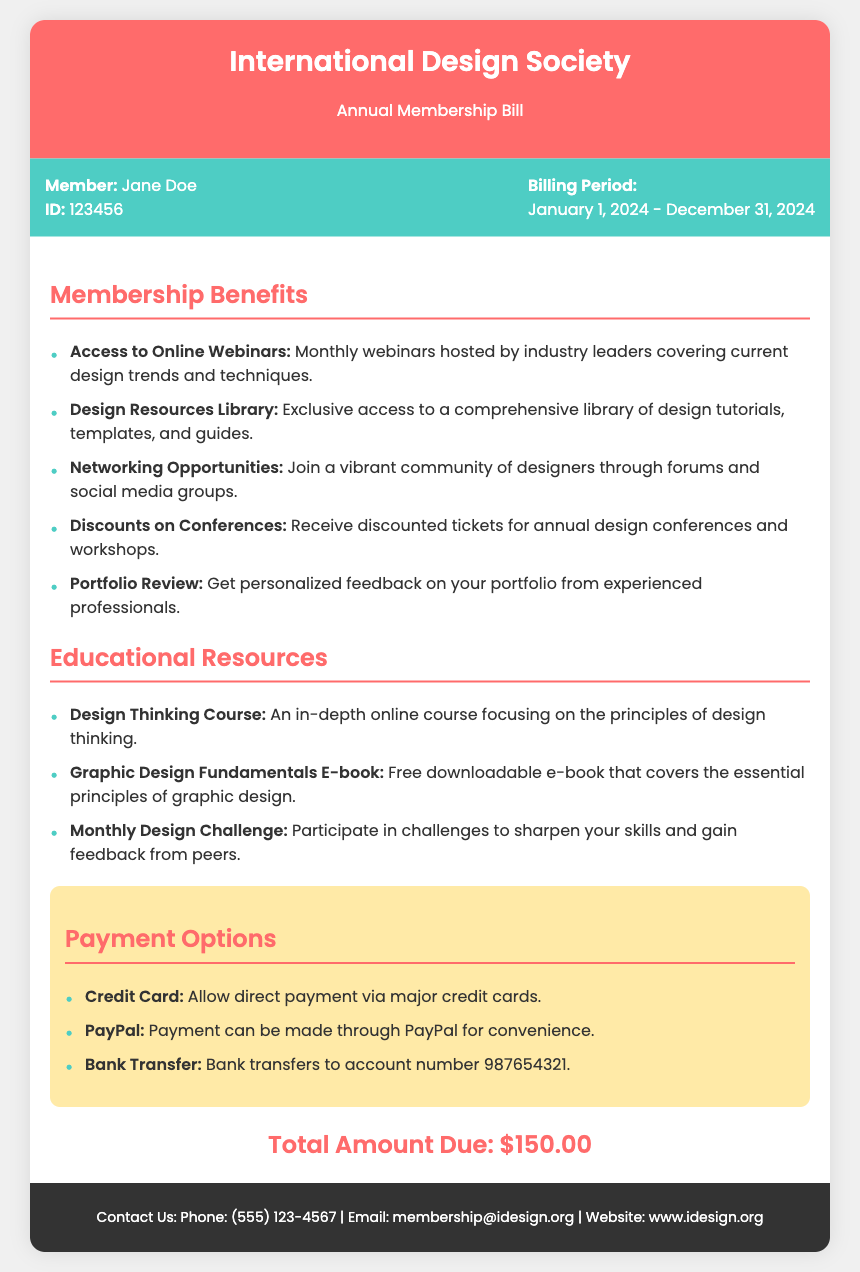what is the name of the organization? The name of the organization is mentioned in the header of the document.
Answer: International Design Society what is the billing period? The billing period is specified in the member info section of the document.
Answer: January 1, 2024 - December 31, 2024 who is the member? The member's name is included in the member info section of the document.
Answer: Jane Doe how much is the total amount due? The total amount due is clearly stated in the document.
Answer: $150.00 what is one benefit of membership? The document lists several benefits of membership; one example is indicated in the benefits section.
Answer: Access to Online Webinars name one educational resource available. The document includes multiple educational resources; one can be found in the educational resources section.
Answer: Design Thinking Course what payment method is mentioned for convenience? The document specifies different payment options, and one is highlighted for convenience.
Answer: PayPal how many educational resources are listed? The document outlines the number of educational resources available to members.
Answer: Three what is a discount offered to members? The document mentions discounts available for members, which can be retrieved from the benefits section.
Answer: Discounts on Conferences 